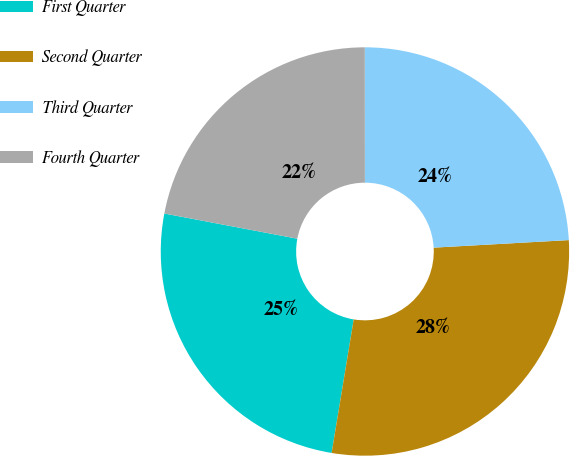Convert chart to OTSL. <chart><loc_0><loc_0><loc_500><loc_500><pie_chart><fcel>First Quarter<fcel>Second Quarter<fcel>Third Quarter<fcel>Fourth Quarter<nl><fcel>25.37%<fcel>28.5%<fcel>24.12%<fcel>22.01%<nl></chart> 